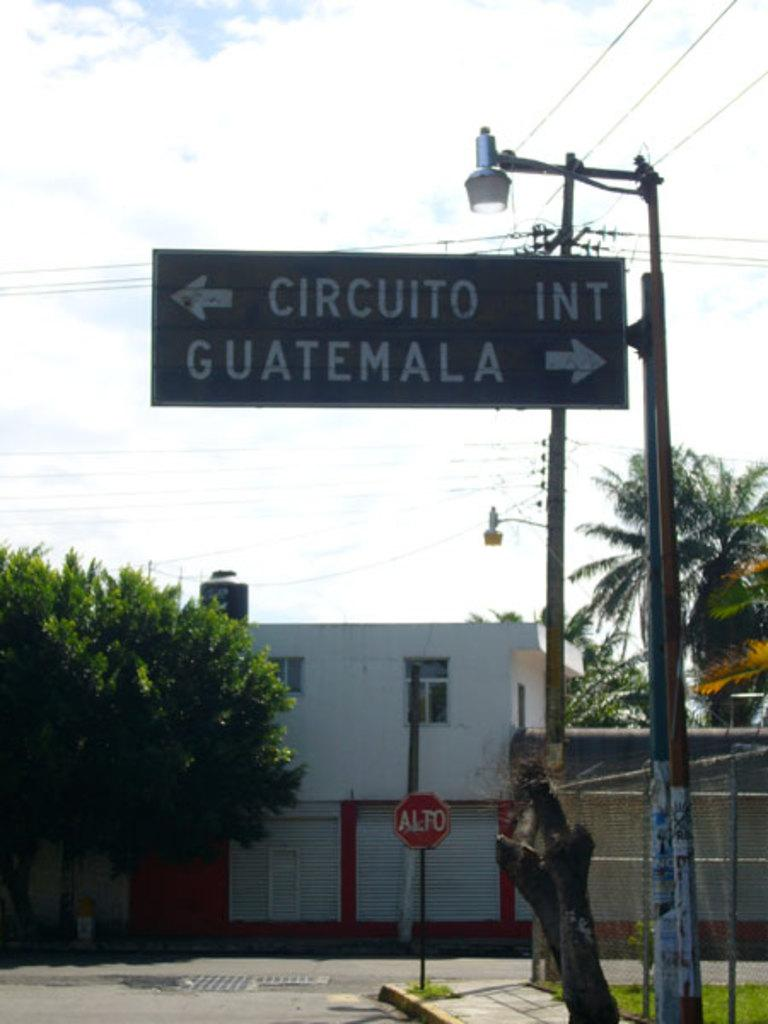What type of natural elements can be seen in the image? There are trees in the image. What type of man-made structures are present in the image? There are houses in the image. What type of information might be conveyed by the sign boards in the image? The sign boards in the image might convey information such as directions, warnings, or advertisements. What advice is given by the trees in the image? There is no advice given by the trees in the image, as trees do not have the ability to provide advice. 